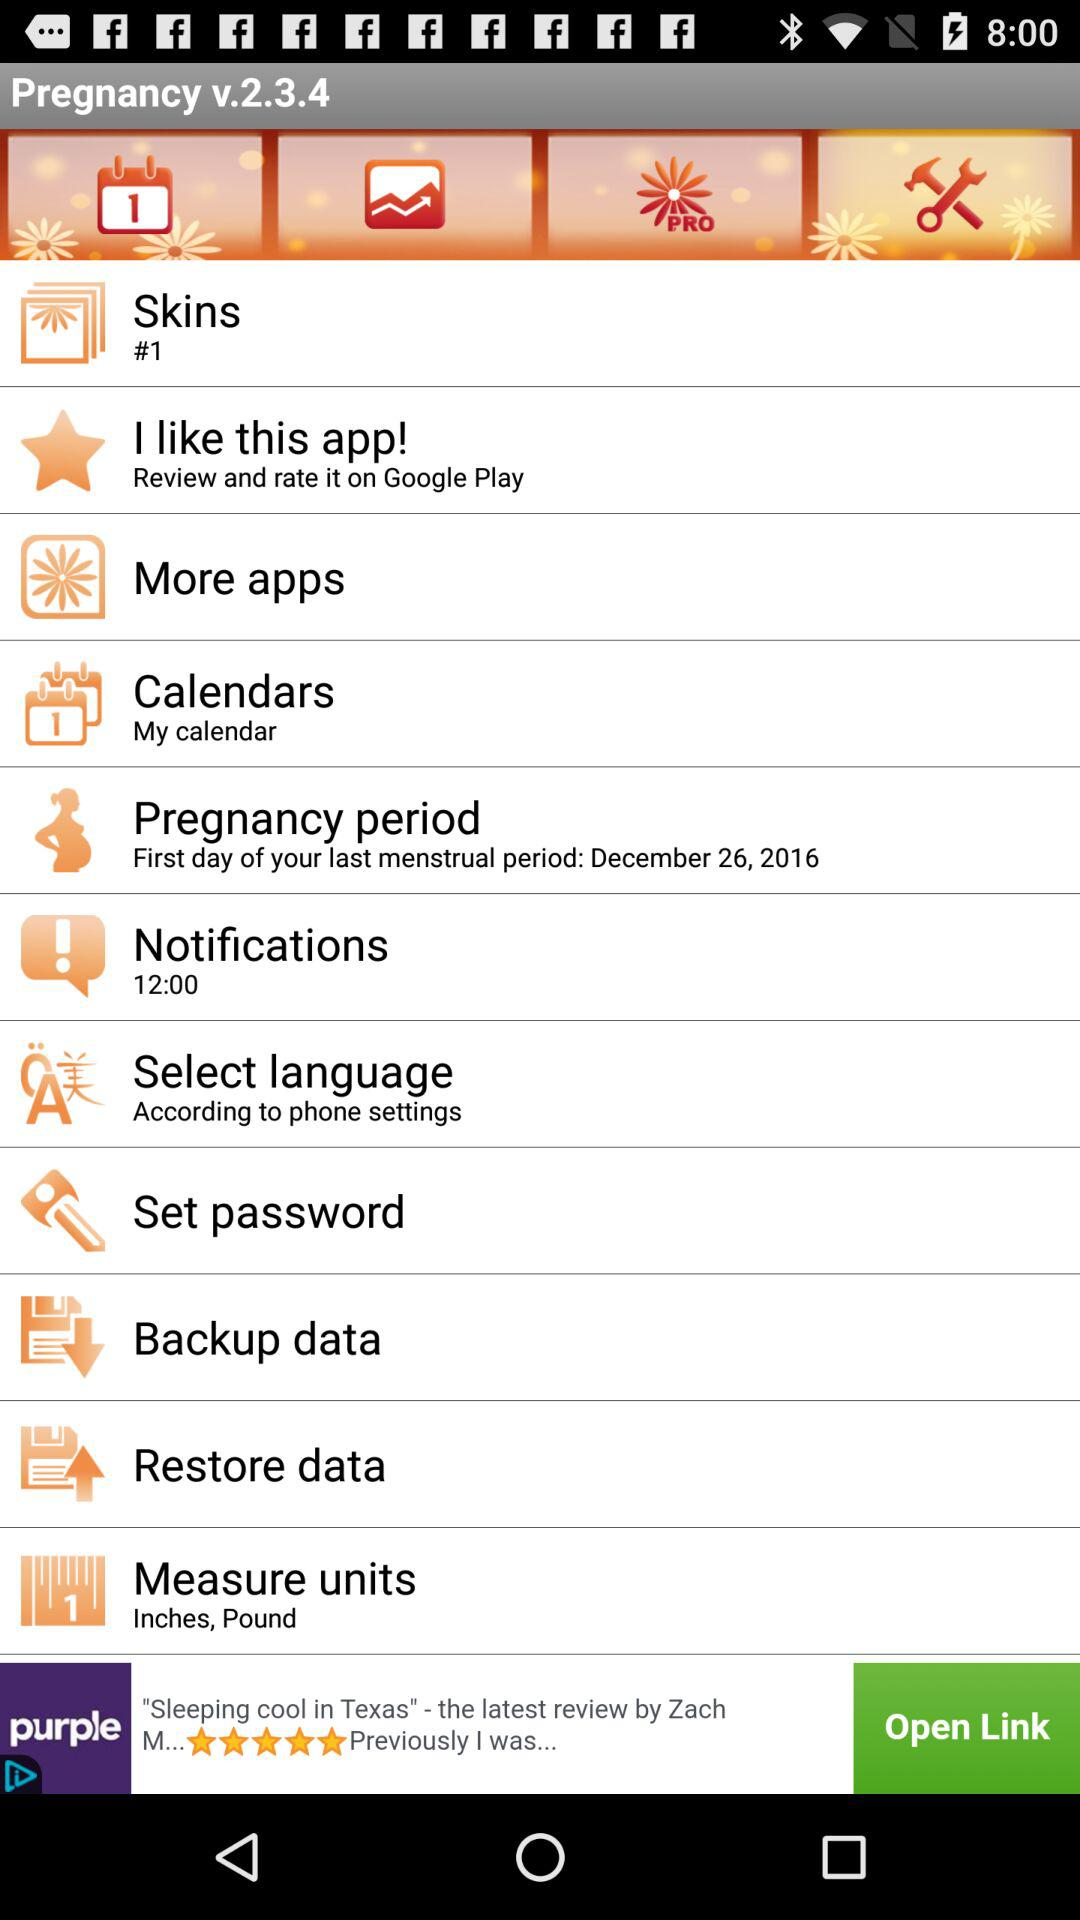What's the "Select Language"? The Select Language is "According to phone settings". 